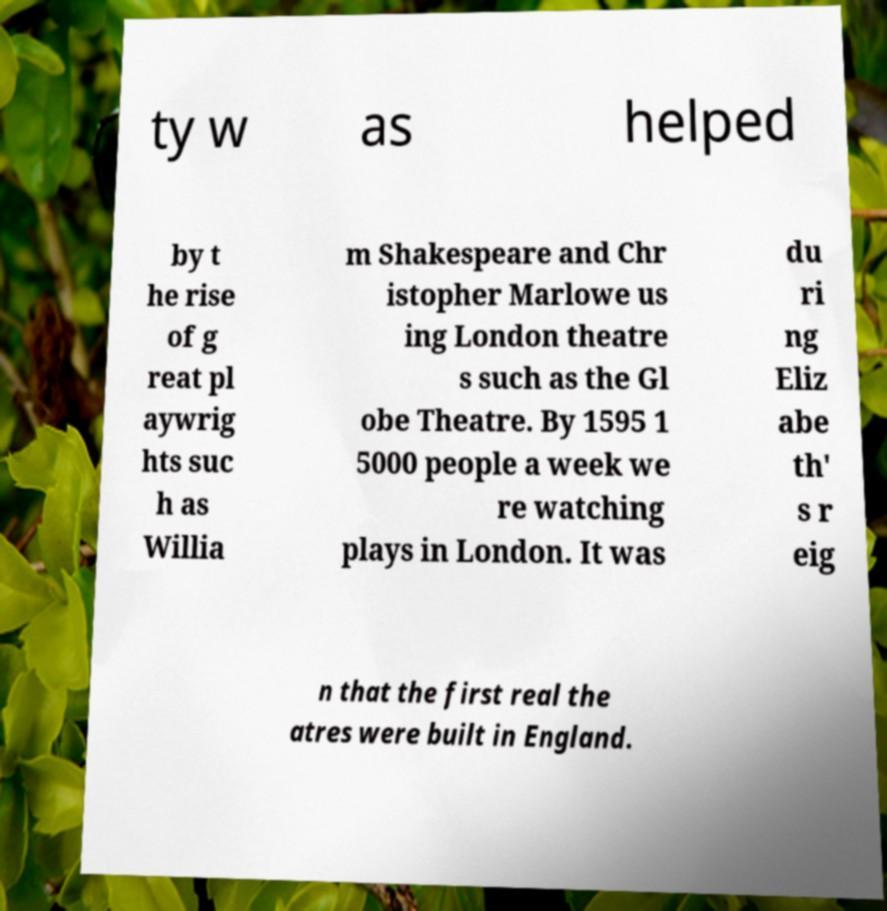Can you accurately transcribe the text from the provided image for me? ty w as helped by t he rise of g reat pl aywrig hts suc h as Willia m Shakespeare and Chr istopher Marlowe us ing London theatre s such as the Gl obe Theatre. By 1595 1 5000 people a week we re watching plays in London. It was du ri ng Eliz abe th' s r eig n that the first real the atres were built in England. 